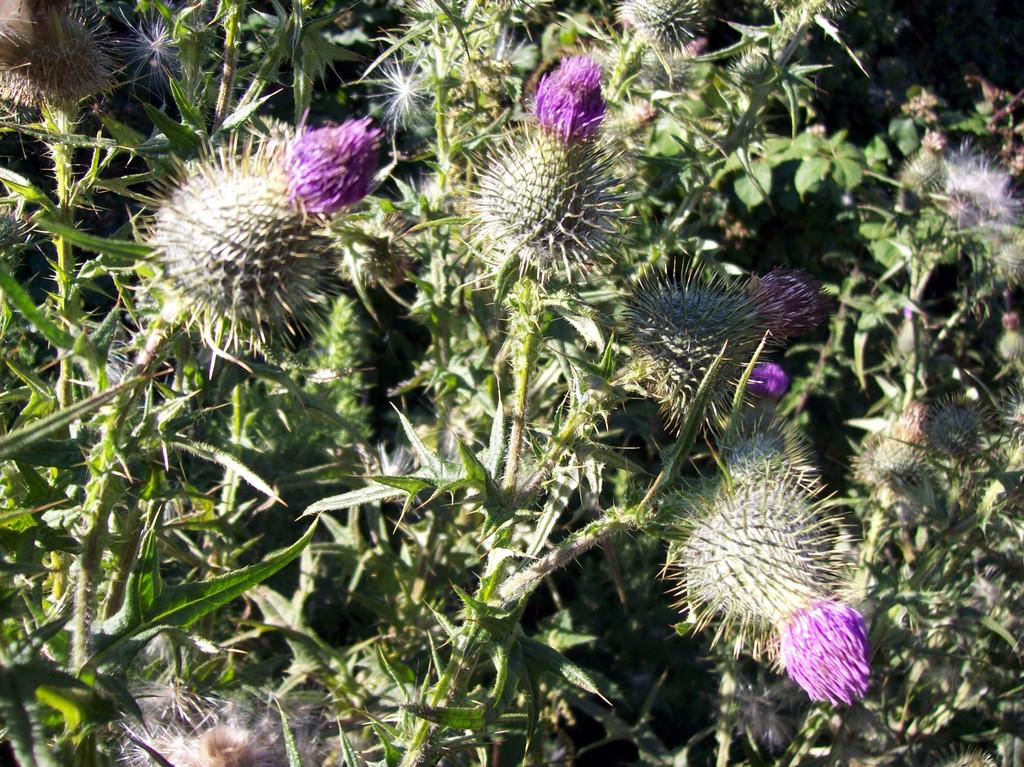What type of living organisms can be seen in the image? Plants can be seen in the image. Do the plants have any specific features? Yes, the plants have flowers. What type of boats can be seen sailing in the background of the image? There are no boats present in the image; it features plants with flowers. 